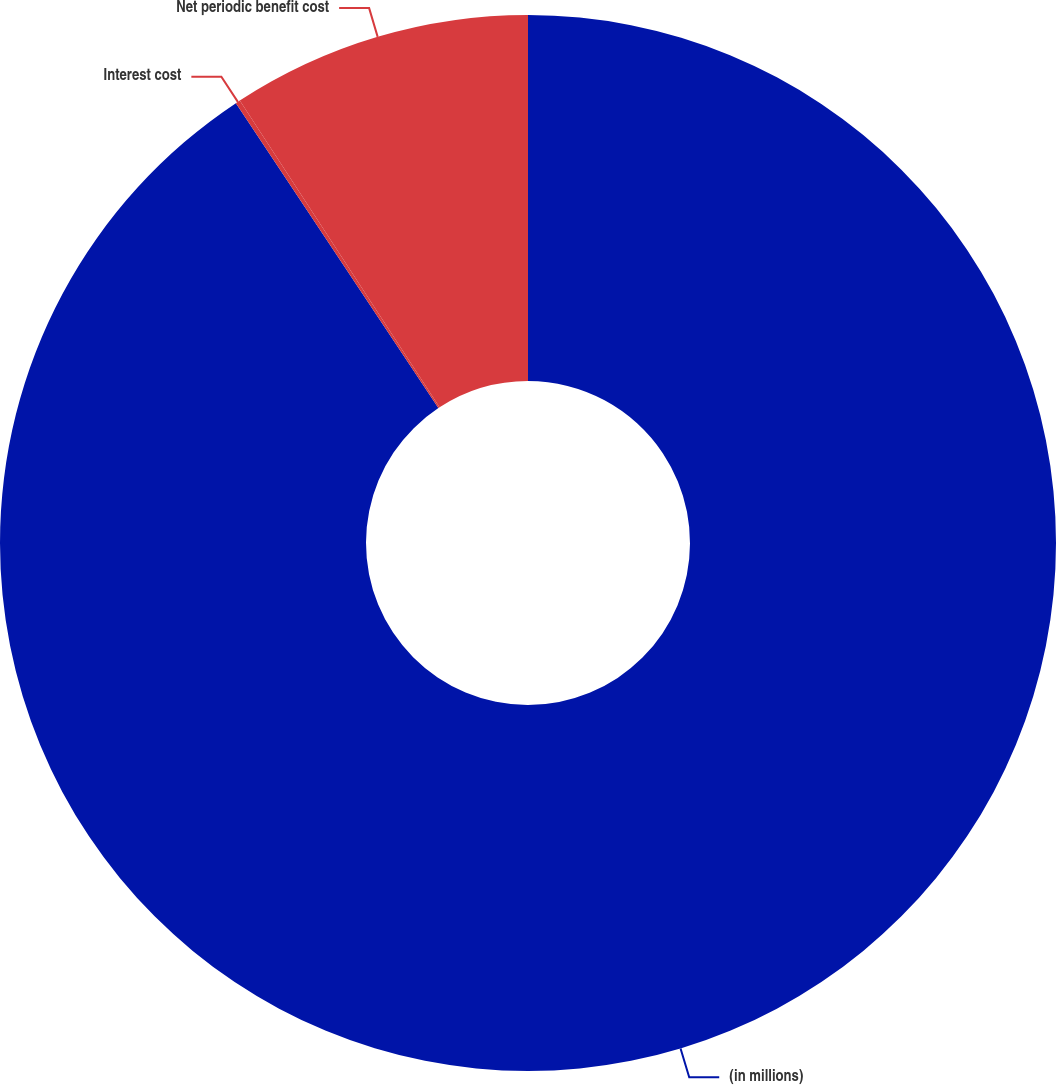<chart> <loc_0><loc_0><loc_500><loc_500><pie_chart><fcel>(in millions)<fcel>Interest cost<fcel>Net periodic benefit cost<nl><fcel>90.67%<fcel>0.14%<fcel>9.19%<nl></chart> 